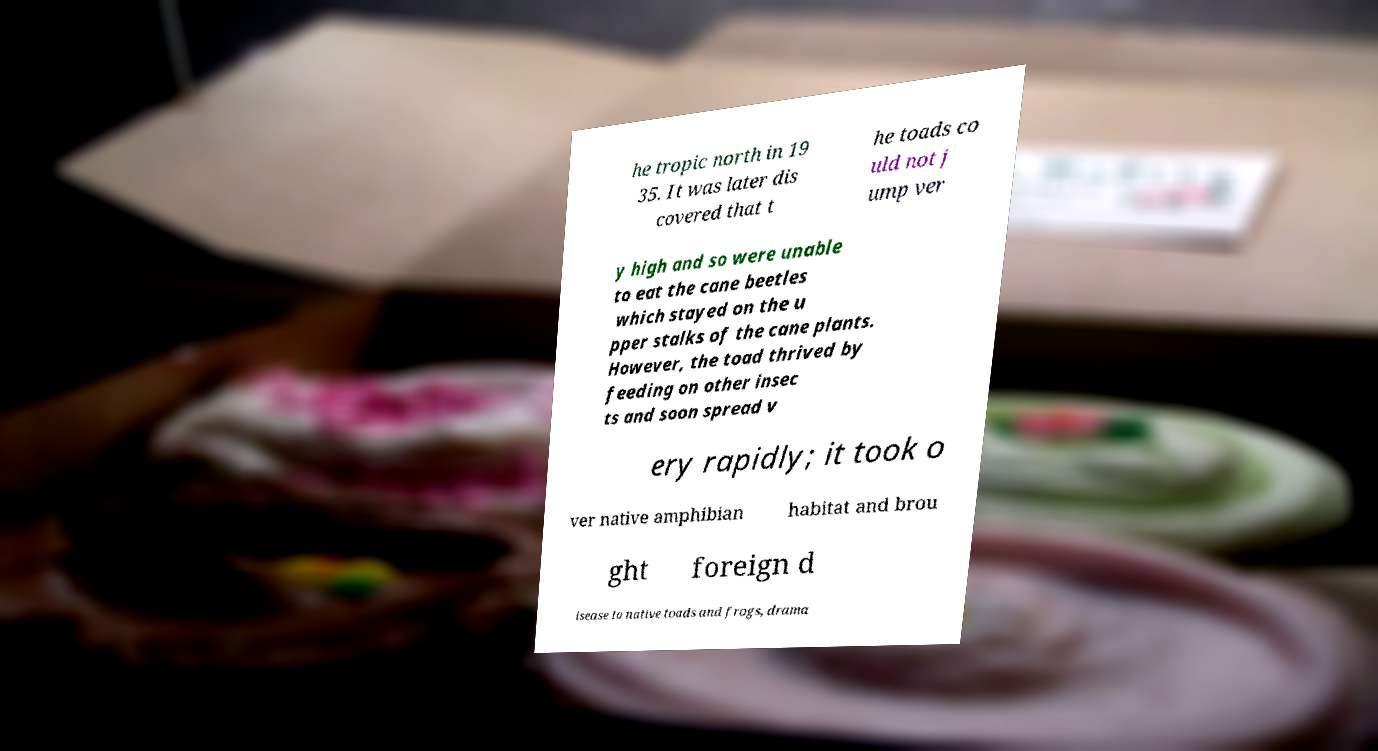Can you accurately transcribe the text from the provided image for me? he tropic north in 19 35. It was later dis covered that t he toads co uld not j ump ver y high and so were unable to eat the cane beetles which stayed on the u pper stalks of the cane plants. However, the toad thrived by feeding on other insec ts and soon spread v ery rapidly; it took o ver native amphibian habitat and brou ght foreign d isease to native toads and frogs, drama 